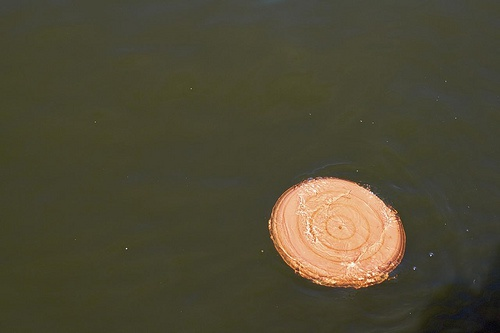Describe the objects in this image and their specific colors. I can see a frisbee in black, tan, and brown tones in this image. 